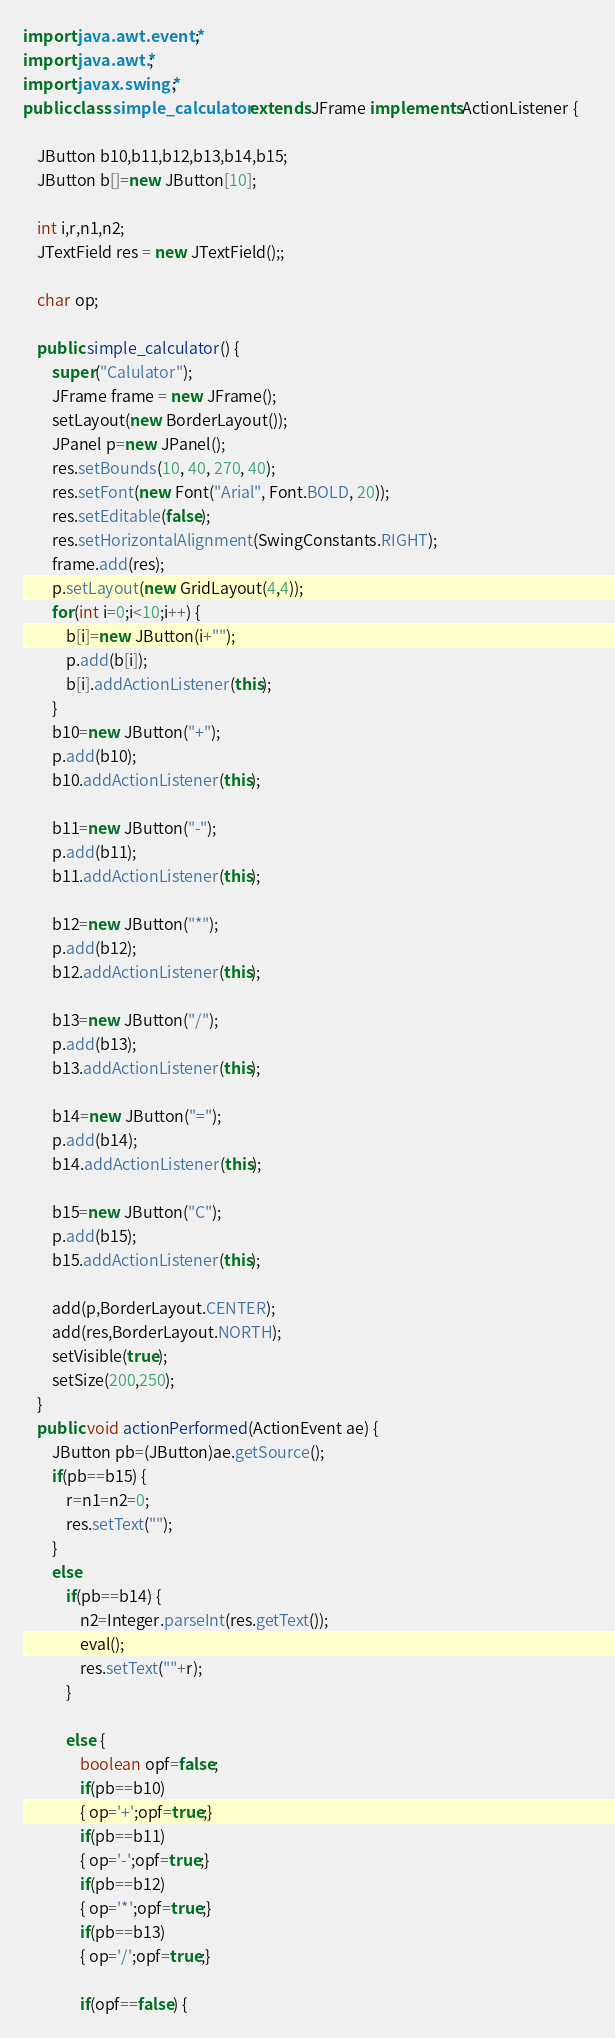<code> <loc_0><loc_0><loc_500><loc_500><_Java_>import java.awt.event.*;
import java.awt.*;
import javax.swing.*;
public class simple_calculator extends JFrame implements ActionListener {    
    
    JButton b10,b11,b12,b13,b14,b15; 
    JButton b[]=new JButton[10];

    int i,r,n1,n2;
    JTextField res = new JTextField();;

    char op; 

    public simple_calculator() {
        super("Calulator");
        JFrame frame = new JFrame();
        setLayout(new BorderLayout());
        JPanel p=new JPanel();
        res.setBounds(10, 40, 270, 40);
        res.setFont(new Font("Arial", Font.BOLD, 20));
        res.setEditable(false);
        res.setHorizontalAlignment(SwingConstants.RIGHT);
        frame.add(res);
        p.setLayout(new GridLayout(4,4));
        for(int i=0;i<10;i++) {
            b[i]=new JButton(i+"");
            p.add(b[i]);
            b[i].addActionListener(this);
        }
        b10=new JButton("+");
        p.add(b10);
        b10.addActionListener(this);
        
        b11=new JButton("-");
        p.add(b11);
        b11.addActionListener(this);
        
        b12=new JButton("*");
        p.add(b12);
        b12.addActionListener(this);
        
        b13=new JButton("/");
        p.add(b13);
        b13.addActionListener(this);
        
        b14=new JButton("=");
        p.add(b14);
        b14.addActionListener(this);
        
        b15=new JButton("C");
        p.add(b15);
        b15.addActionListener(this);
        
        add(p,BorderLayout.CENTER);
        add(res,BorderLayout.NORTH);
        setVisible(true);
        setSize(200,250);
    }
    public void actionPerformed(ActionEvent ae) {
        JButton pb=(JButton)ae.getSource();
        if(pb==b15) {
            r=n1=n2=0;
            res.setText("");
        }
        else
            if(pb==b14) {
                n2=Integer.parseInt(res.getText());
                eval();
                res.setText(""+r);
            }
            
            else {
                boolean opf=false;
                if(pb==b10)
                { op='+';opf=true;}
                if(pb==b11)
                { op='-';opf=true;}
                if(pb==b12)
                { op='*';opf=true;}
                if(pb==b13)
                { op='/';opf=true;}
                
                if(opf==false) {</code> 